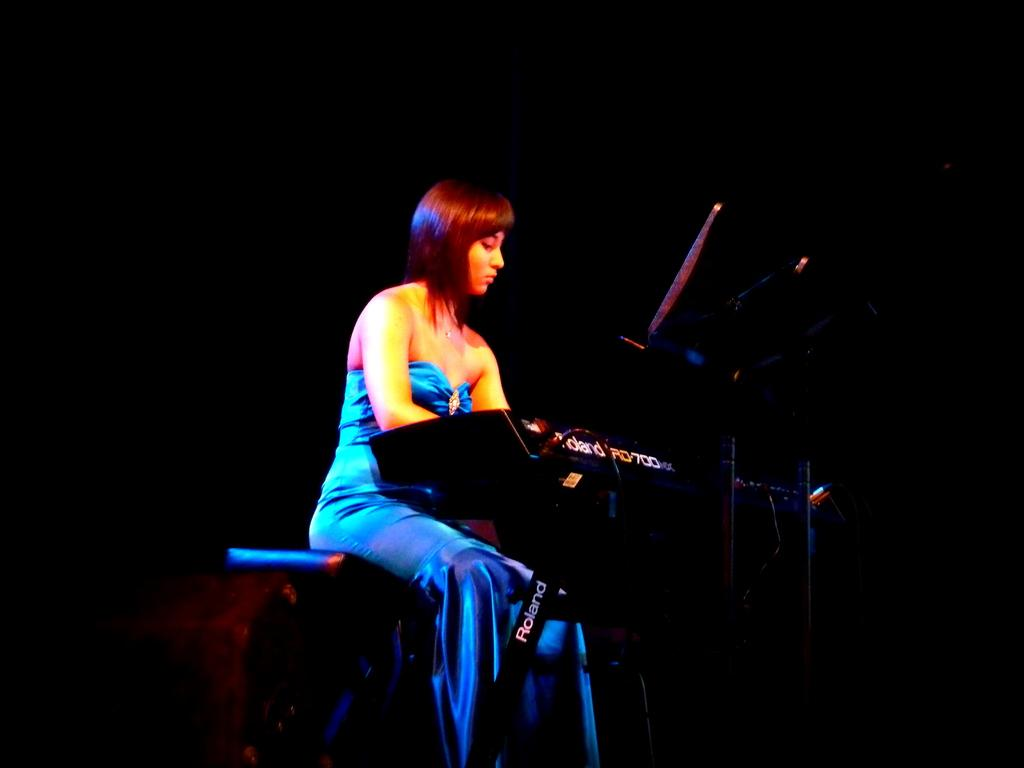What is the main subject of the image? There is a beautiful woman in the image. What is the woman doing in the image? The woman is sitting and playing a musical instrument. What is the woman wearing in the image? The woman is wearing a blue dress. How many apples are on the woman's head in the image? There are no apples present on the woman's head in the image. What type of bushes can be seen surrounding the woman in the image? There are no bushes visible in the image; it only features the woman sitting and playing a musical instrument. 